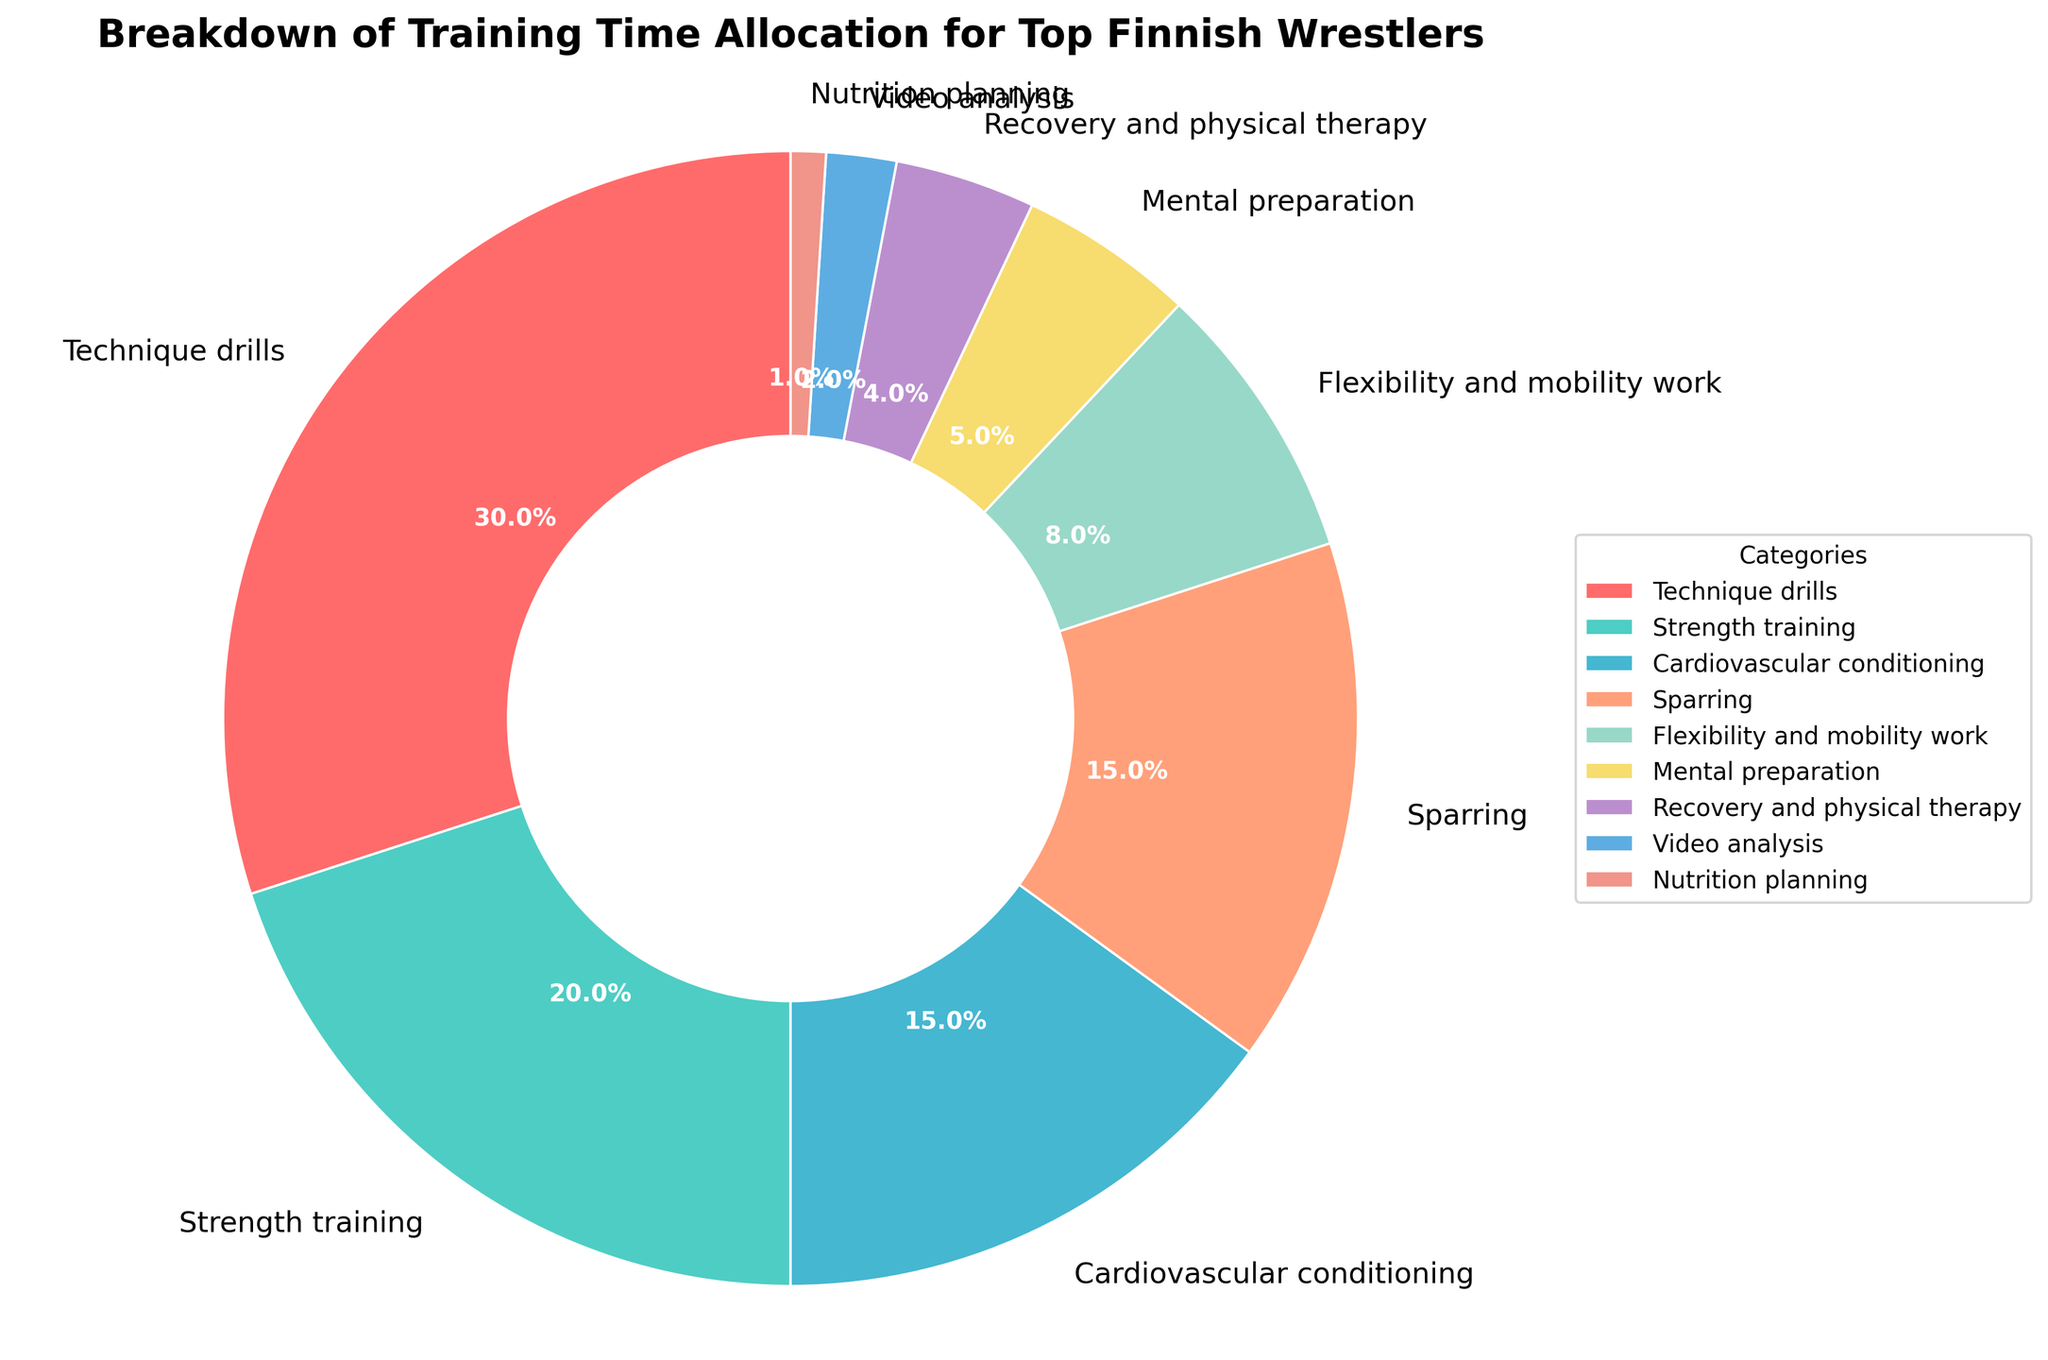What is the largest category in the training time allocation? The largest category can be identified by looking at the segment with the largest percentage. "Technique drills" takes up 30% of the training time, which is the highest among all categories.
Answer: Technique drills Which category takes up more time: Sparring or Cardiovascular conditioning? To find this, compare the percentages of the two categories. Sparring is 15% and Cardiovascular conditioning is also 15%. Since they are equal, neither takes up more time than the other.
Answer: Equal How much more time is allocated to Strength training compared to Recovery and physical therapy? To determine the difference, subtract the percentage of Recovery and physical therapy from that of Strength training. Strength training is 20% and Recovery and physical therapy is 4%. The difference is 20% - 4% = 16%.
Answer: 16% What is the total percentage of time allocated to activities focused on physical well-being (Strength training, Cardiovascular conditioning, Flexibility and mobility work, Recovery and physical therapy)? Sum the percentages of all physical well-being activities: Strength training (20%), Cardiovascular conditioning (15%), Flexibility and mobility work (8%), Recovery and physical therapy (4%). The total is 20% + 15% + 8% + 4% = 47%.
Answer: 47% Which category is represented by a red segment? The segment colors match the order of categories listed in the data. As the first category listed is Technique drills, and the custom color arrangement starts with red, the red segment represents Technique drills.
Answer: Technique drills Are the percentages of Nutrition planning and Mental preparation a combined total greater than the percentage of Flexibility and mobility work? Sum the percentages of Nutrition planning and Mental preparation first: 1% + 5% = 6%. Compare it with Flexibility and mobility work which is 8%. Since 6% < 8%, the combined total is not greater.
Answer: No What is the percentage difference between Technique drills and the least allocated category? Identify the least allocated category, which is Nutrition planning at 1%. Then, subtract this from Technique drills' 30%. The difference is 30% - 1% = 29%.
Answer: 29% Which segment represents the smallest allocation of training time? The smallest segment corresponds to the category with the lowest percentage. Nutrition planning is allocated only 1% of training time, making it the smallest segment.
Answer: Nutrition planning 